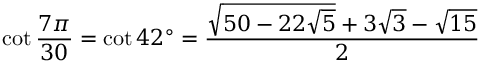<formula> <loc_0><loc_0><loc_500><loc_500>\cot { \frac { 7 \pi } { 3 0 } } = \cot 4 2 ^ { \circ } = { \frac { { \sqrt { 5 0 - 2 2 { \sqrt { 5 } } } } + 3 { \sqrt { 3 } } - { \sqrt { 1 5 } } } { 2 } }</formula> 